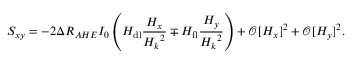<formula> <loc_0><loc_0><loc_500><loc_500>S _ { x y } = - 2 \Delta R _ { A H E } I _ { 0 } \left ( H _ { d l } \frac { H _ { x } } { { H _ { k } } ^ { 2 } } \mp H _ { f l } \frac { H _ { y } } { { H _ { k } } ^ { 2 } } \right ) + \mathcal { O } [ H _ { x } ] ^ { 2 } + \mathcal { O } [ H _ { y } ] ^ { 2 } .</formula> 